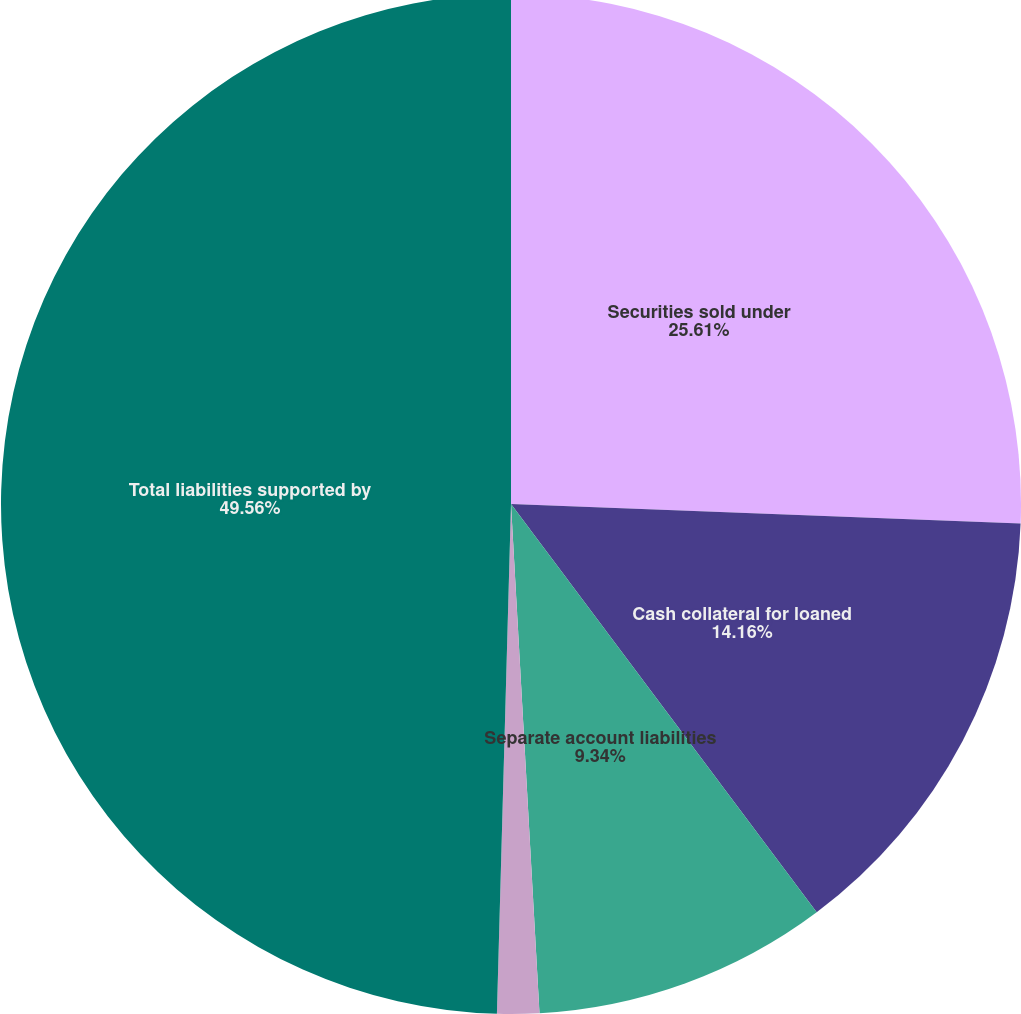Convert chart. <chart><loc_0><loc_0><loc_500><loc_500><pie_chart><fcel>Securities sold under<fcel>Cash collateral for loaned<fcel>Separate account liabilities<fcel>Policyholders' account<fcel>Total liabilities supported by<nl><fcel>25.61%<fcel>14.16%<fcel>9.34%<fcel>1.33%<fcel>49.56%<nl></chart> 